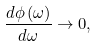<formula> <loc_0><loc_0><loc_500><loc_500>\frac { d \phi \left ( \omega \right ) } { d \omega } \rightarrow 0 ,</formula> 